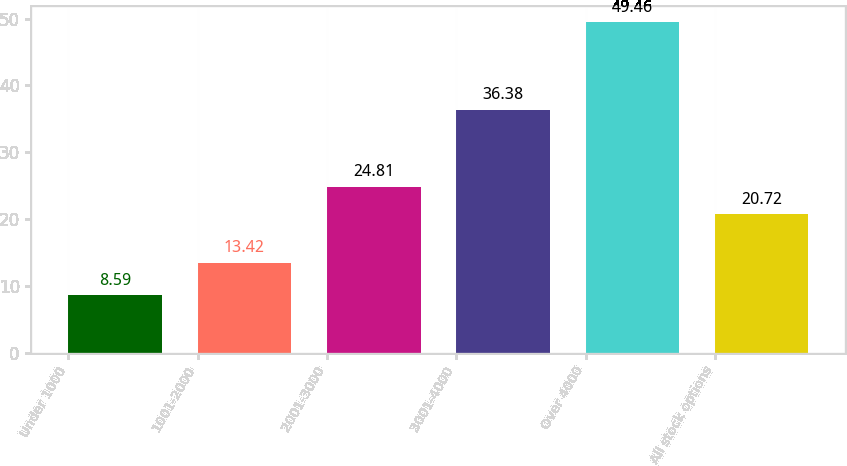Convert chart to OTSL. <chart><loc_0><loc_0><loc_500><loc_500><bar_chart><fcel>Under 1000<fcel>1001-2000<fcel>2001-3000<fcel>3001-4000<fcel>Over 4000<fcel>All stock options<nl><fcel>8.59<fcel>13.42<fcel>24.81<fcel>36.38<fcel>49.46<fcel>20.72<nl></chart> 